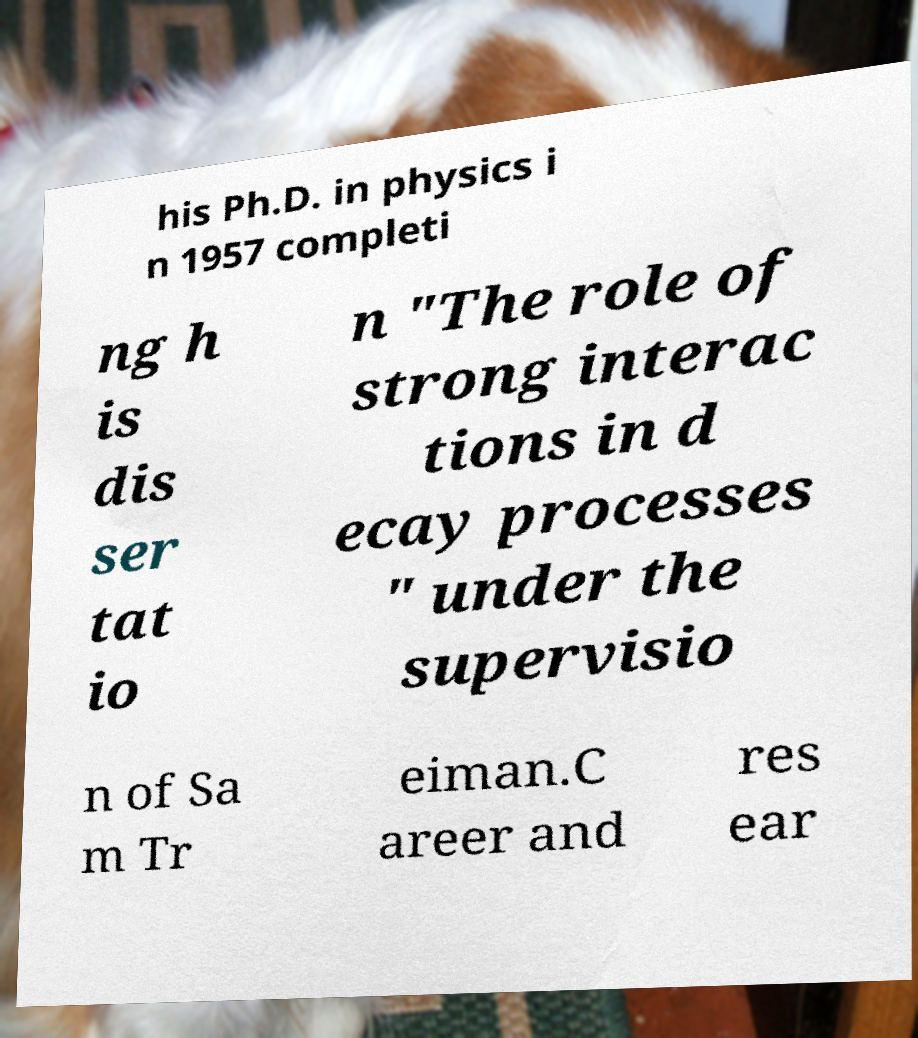I need the written content from this picture converted into text. Can you do that? his Ph.D. in physics i n 1957 completi ng h is dis ser tat io n "The role of strong interac tions in d ecay processes " under the supervisio n of Sa m Tr eiman.C areer and res ear 